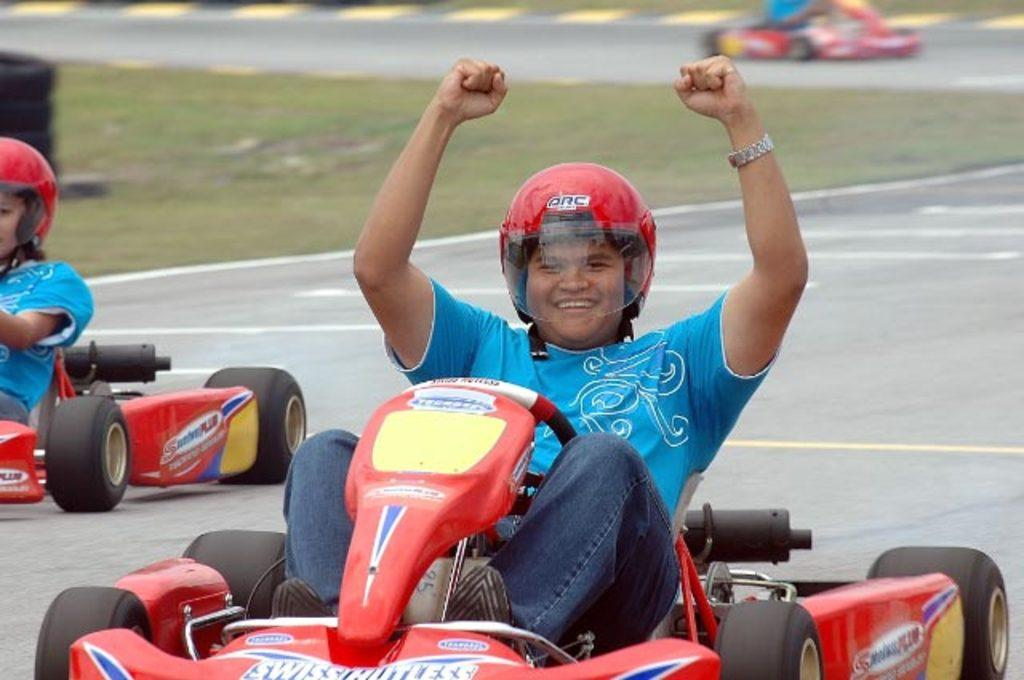What is the person in the image doing? The person is sitting on a go-kart vehicle. How does the person appear to feel in the image? The person is smiling. Who else is present in the image? There is a woman sitting on a go-kart vehicle. Where is the woman positioned in relation to the person? The woman is on the left side of the person. What type of cake is being served on the go-kart vehicles in the image? There is no cake present in the image; it features two people sitting on go-kart vehicles. How many planes can be seen flying in the background of the image? There are no planes visible in the image; it focuses on the two people sitting on go-kart vehicles. 